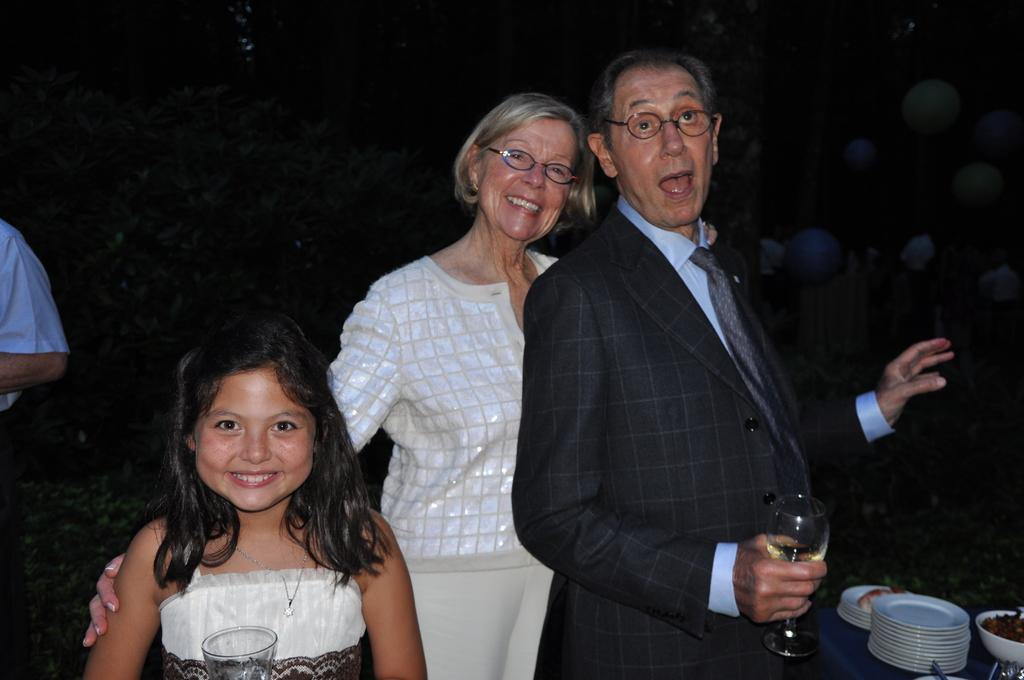Please provide a concise description of this image. In this image we can see people standing and some of them are holding wine glasses. In the background there are balloons. On the right there is a table and we can see plates, bowls, spoons and some food placed on the table. 